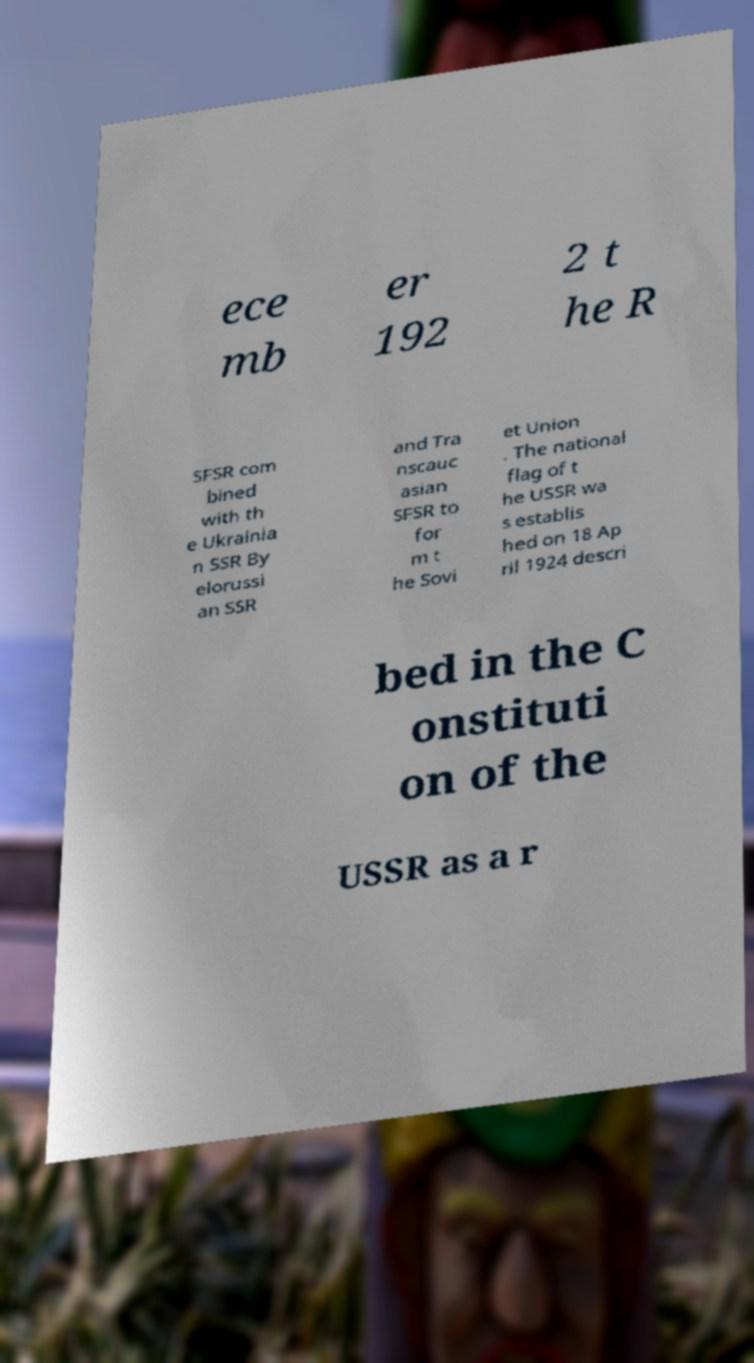Could you assist in decoding the text presented in this image and type it out clearly? ece mb er 192 2 t he R SFSR com bined with th e Ukrainia n SSR By elorussi an SSR and Tra nscauc asian SFSR to for m t he Sovi et Union . The national flag of t he USSR wa s establis hed on 18 Ap ril 1924 descri bed in the C onstituti on of the USSR as a r 